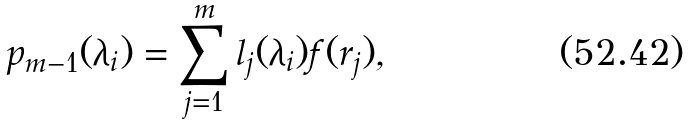Convert formula to latex. <formula><loc_0><loc_0><loc_500><loc_500>p _ { m - 1 } ( \lambda _ { i } ) = \sum _ { j = 1 } ^ { m } l _ { j } ( \lambda _ { i } ) f ( r _ { j } ) ,</formula> 